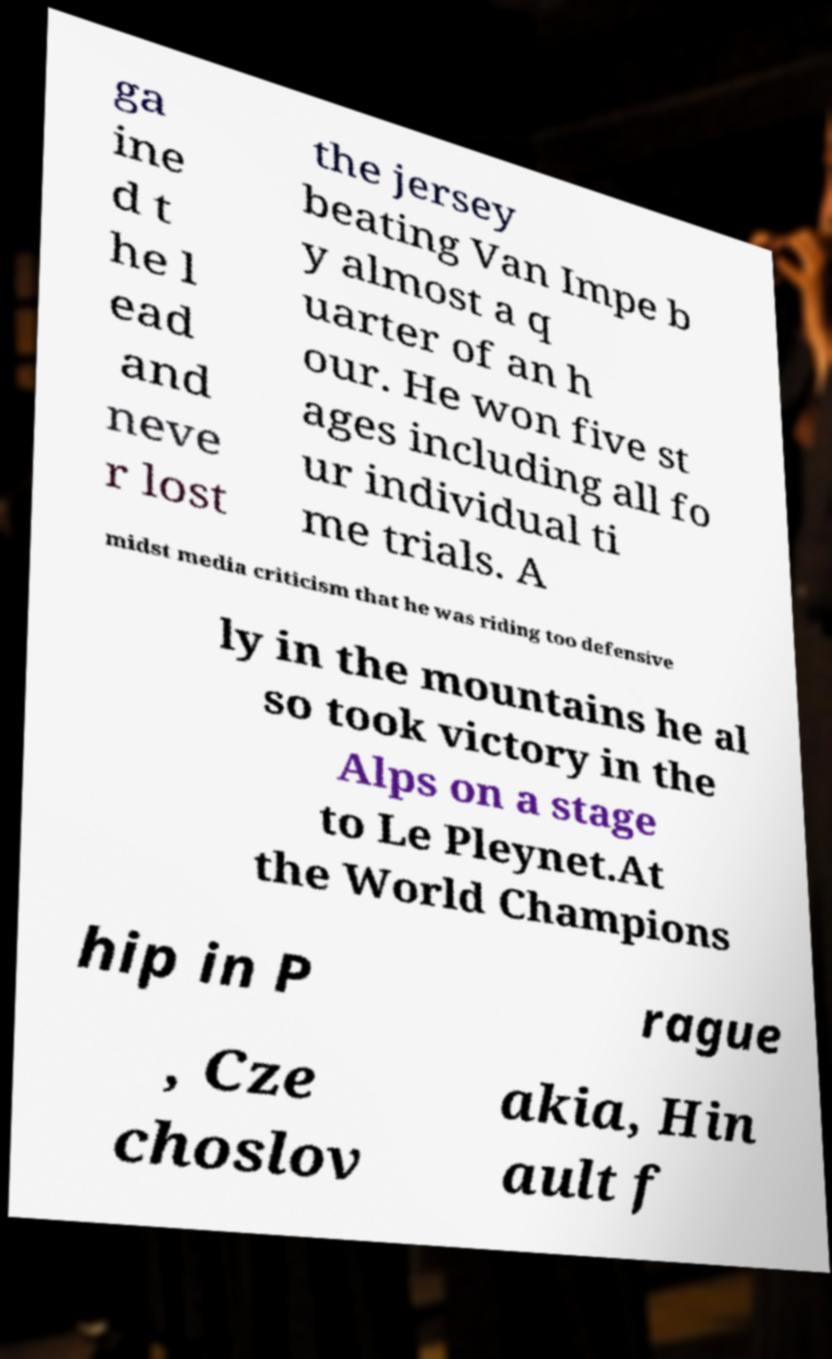Could you assist in decoding the text presented in this image and type it out clearly? ga ine d t he l ead and neve r lost the jersey beating Van Impe b y almost a q uarter of an h our. He won five st ages including all fo ur individual ti me trials. A midst media criticism that he was riding too defensive ly in the mountains he al so took victory in the Alps on a stage to Le Pleynet.At the World Champions hip in P rague , Cze choslov akia, Hin ault f 